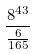<formula> <loc_0><loc_0><loc_500><loc_500>\frac { 8 ^ { 4 3 } } { \frac { 6 } { 1 6 5 } }</formula> 